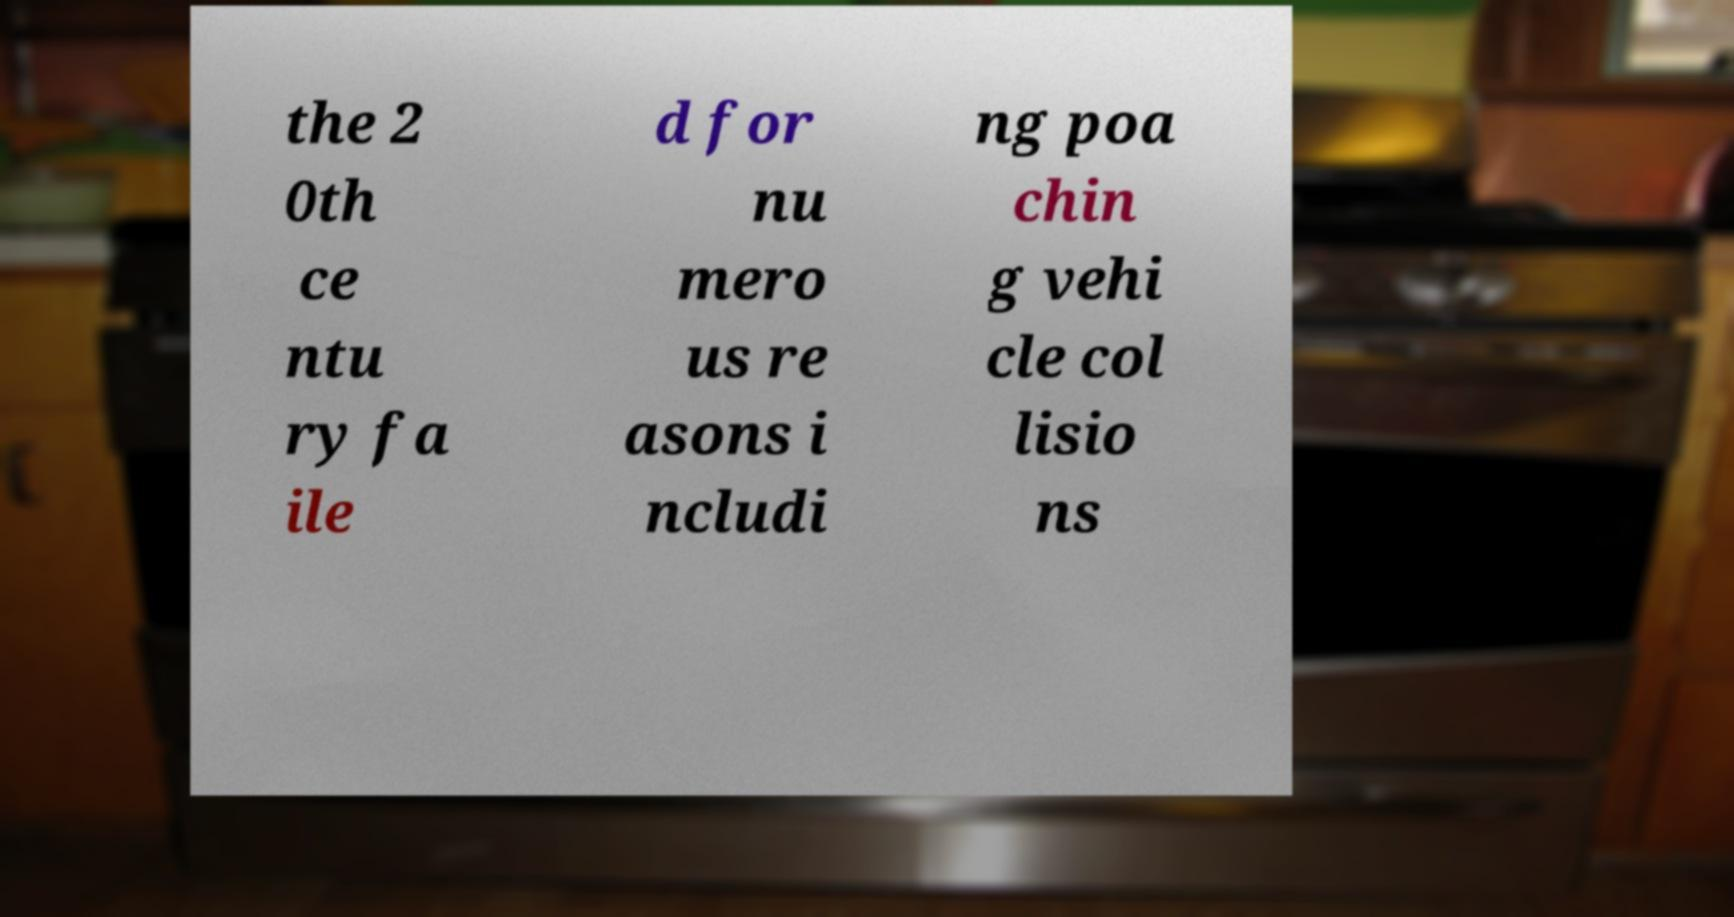Please read and relay the text visible in this image. What does it say? the 2 0th ce ntu ry fa ile d for nu mero us re asons i ncludi ng poa chin g vehi cle col lisio ns 